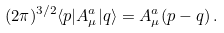<formula> <loc_0><loc_0><loc_500><loc_500>( 2 \pi ) ^ { 3 / 2 } \langle p | A _ { \mu } ^ { a } | q \rangle = A _ { \mu } ^ { a } ( p - q ) \, .</formula> 